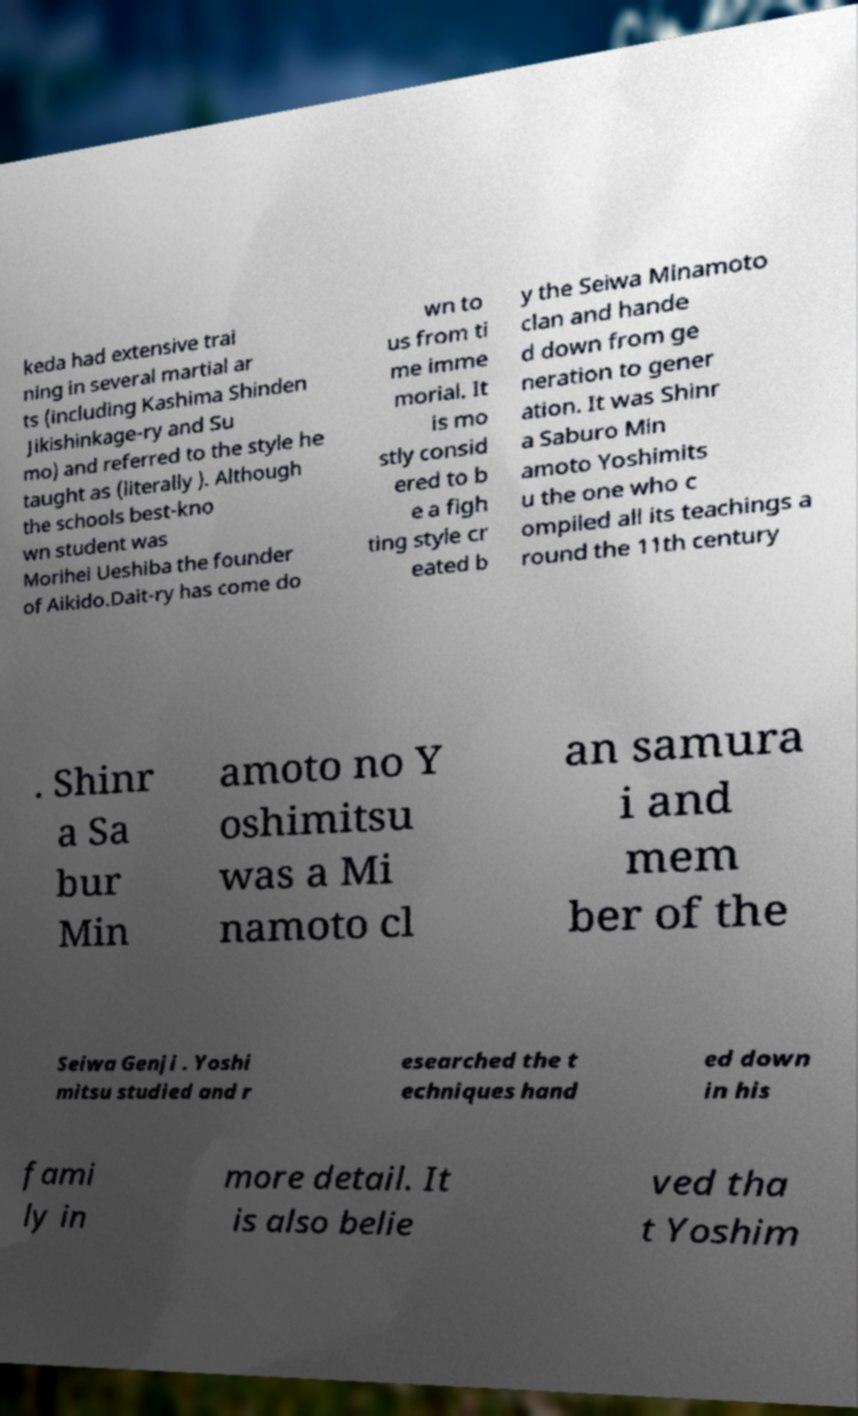Please identify and transcribe the text found in this image. keda had extensive trai ning in several martial ar ts (including Kashima Shinden Jikishinkage-ry and Su mo) and referred to the style he taught as (literally ). Although the schools best-kno wn student was Morihei Ueshiba the founder of Aikido.Dait-ry has come do wn to us from ti me imme morial. It is mo stly consid ered to b e a figh ting style cr eated b y the Seiwa Minamoto clan and hande d down from ge neration to gener ation. It was Shinr a Saburo Min amoto Yoshimits u the one who c ompiled all its teachings a round the 11th century . Shinr a Sa bur Min amoto no Y oshimitsu was a Mi namoto cl an samura i and mem ber of the Seiwa Genji . Yoshi mitsu studied and r esearched the t echniques hand ed down in his fami ly in more detail. It is also belie ved tha t Yoshim 